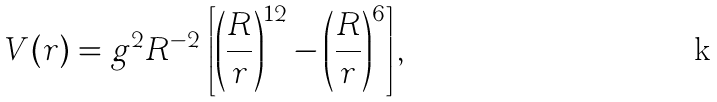<formula> <loc_0><loc_0><loc_500><loc_500>V ( r ) = g ^ { 2 } R ^ { - 2 } \, \left [ \left ( \frac { R } { r } \right ) ^ { 1 2 } - \left ( \frac { R } { r } \right ) ^ { 6 } \right ] ,</formula> 